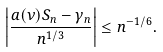<formula> <loc_0><loc_0><loc_500><loc_500>\left | \frac { a ( \nu ) S _ { n } - \gamma _ { n } } { n ^ { 1 / 3 } } \right | \leq n ^ { - 1 / 6 } .</formula> 